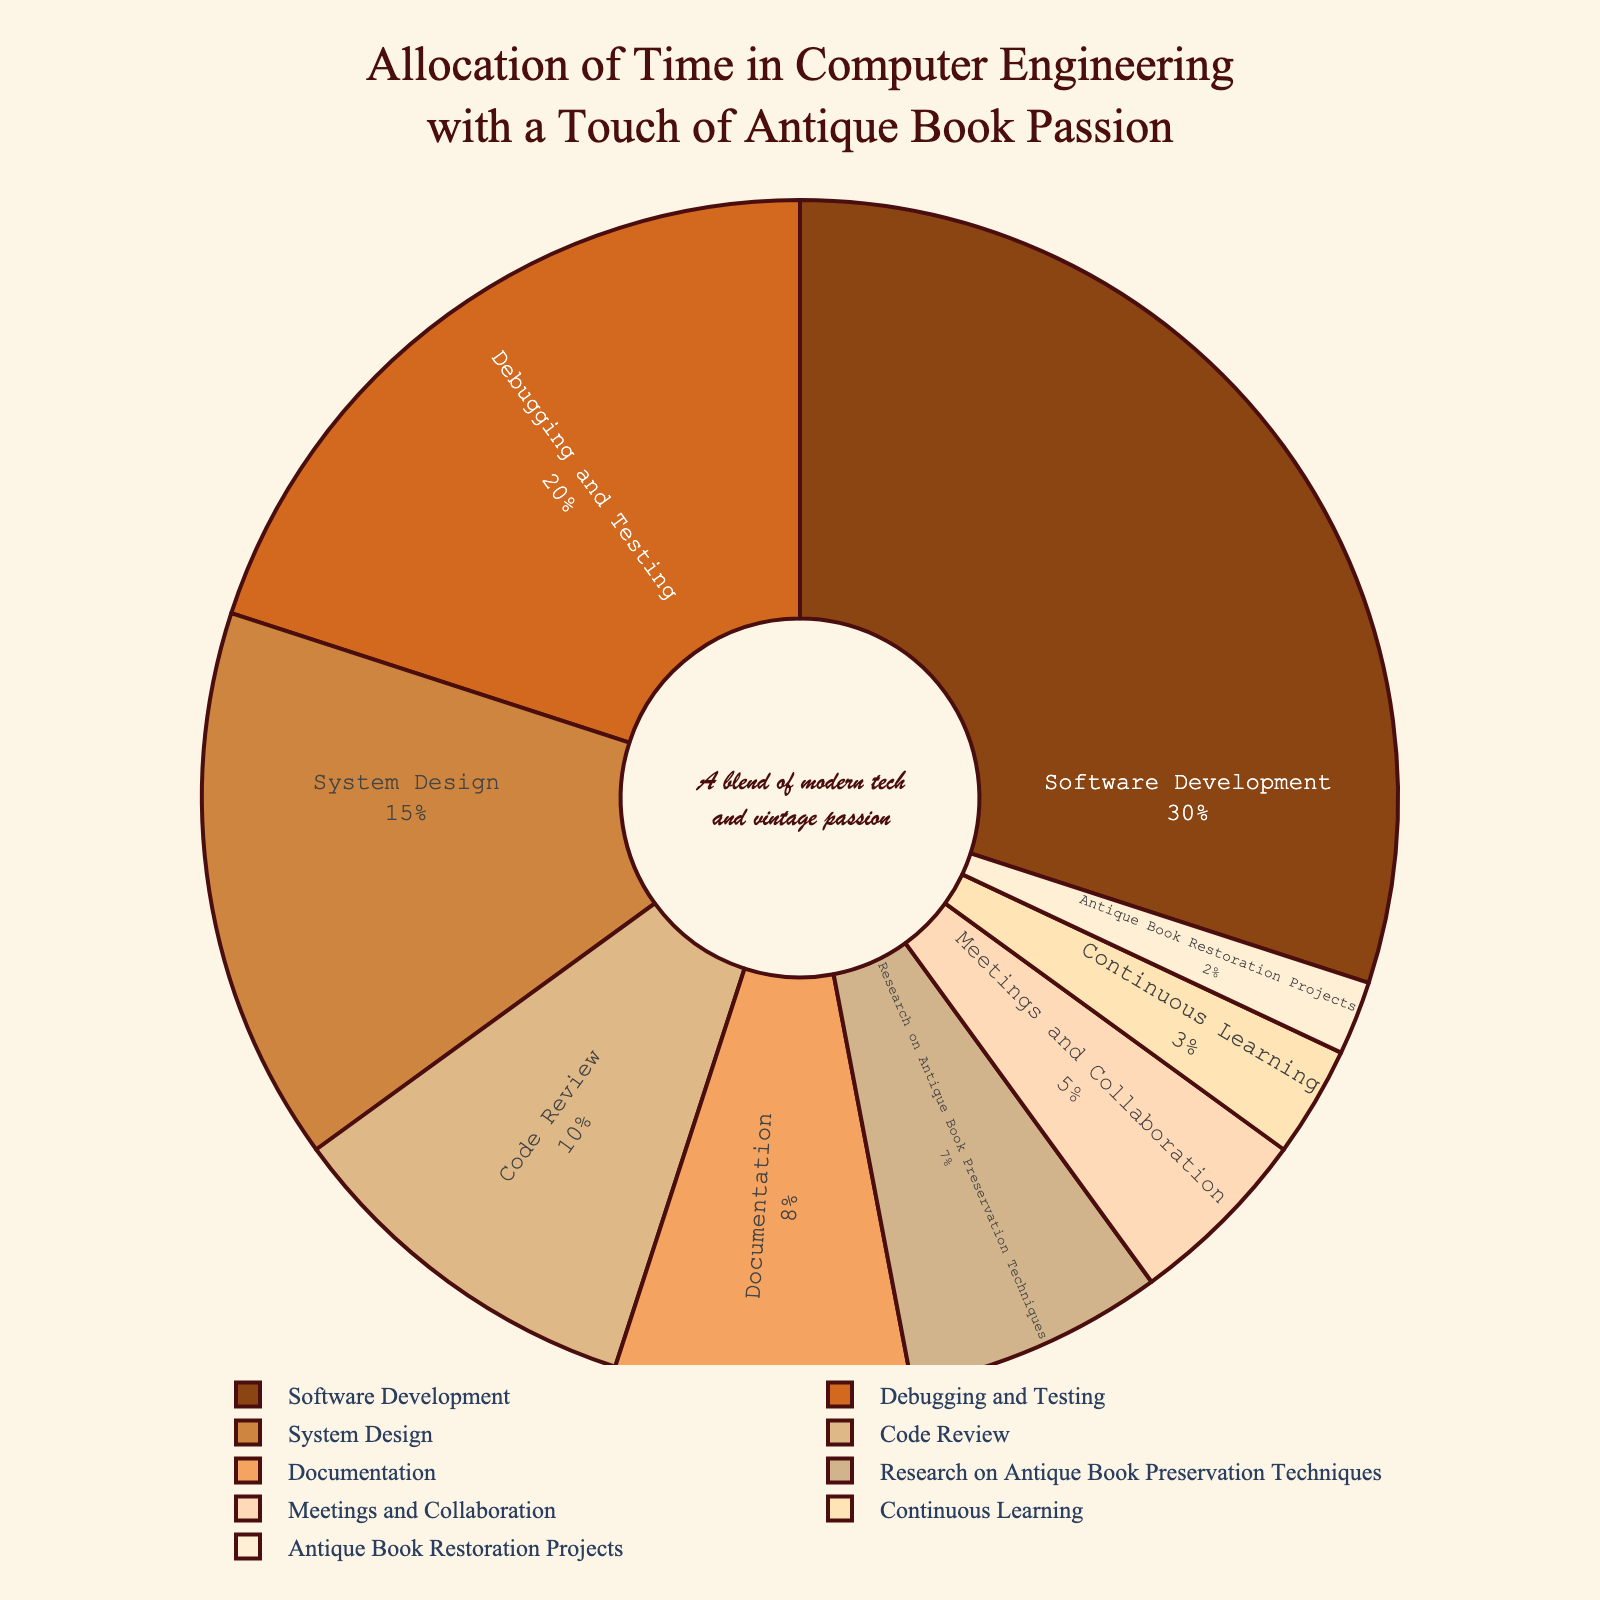Which task takes up the most time according to the pie chart? The largest slice of the pie chart corresponds to Software Development, which takes up the most time.
Answer: Software Development How much more time is spent on Debugging and Testing compared to Documentation? Debugging and Testing takes up 20%, while Documentation takes up 8%. The difference is 20% - 8% = 12%.
Answer: 12% Are Meetings and Collaboration more or less time-consuming than Research on Antique Book Preservation Techniques? Meetings and Collaboration take up 5%, while Research on Antique Book Preservation Techniques takes up 7%. Meetings and Collaboration are less time-consuming.
Answer: Less What percentage of time is allocated to non-technical tasks (documentation, meetings and collaboration, antique book activities)? Documentation (8%), Meetings and Collaboration (5%), Research on Antique Book Preservation (7%), and Antique Book Restoration Projects (2%) sum up to 8% + 5% + 7% + 2% = 22%.
Answer: 22% Is the time spent on Continuous Learning greater than or less than the time spent on Code Review? Continuous Learning takes up 3%, while Code Review takes up 10%. Continuous Learning is less than Code Review.
Answer: Less What is the combined percentage of time spent on System Design and Code Review? System Design takes up 15% and Code Review takes up 10%. Combined, it's 15% + 10% = 25%.
Answer: 25% Considering both professional and antique book-related tasks, which category (professional or antique book-related) takes up more time? Professional tasks sum up Software Development (30%), Debugging and Testing (20%), System Design (15%), Code Review (10%), Documentation (8%), Meetings and Collaboration (5%), and Continuous Learning (3%) which totals 91%. Antique book-related tasks sum up Research on Antique Book Preservation Techniques (7%) and Antique Book Restoration Projects (2%) which is 9%. Professional tasks take more time.
Answer: Professional tasks What is the percentage difference between the time allocated to Research on Antique Book Preservation Techniques and Antique Book Restoration Projects? Research on Antique Book Preservation Techniques takes up 7%, and Antique Book Restoration Projects take up 2%. The difference is 7% - 2% = 5%.
Answer: 5% Which slices of the pie chart have an inner label written in italics? This type of visual attribute isn't detailed in the data provided above. We can't determine italics from just the description of the figure.
Answer: Uncertain 